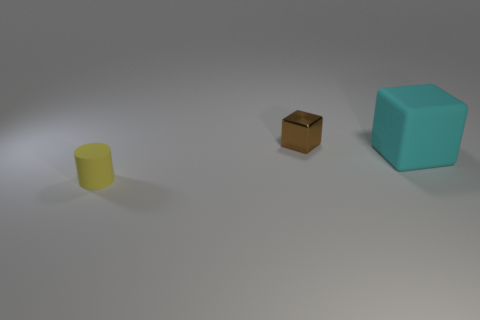Add 1 big red metallic objects. How many objects exist? 4 Subtract all cylinders. How many objects are left? 2 Subtract 1 yellow cylinders. How many objects are left? 2 Subtract all large rubber blocks. Subtract all large cyan things. How many objects are left? 1 Add 3 small brown metal things. How many small brown metal things are left? 4 Add 2 cyan metallic blocks. How many cyan metallic blocks exist? 2 